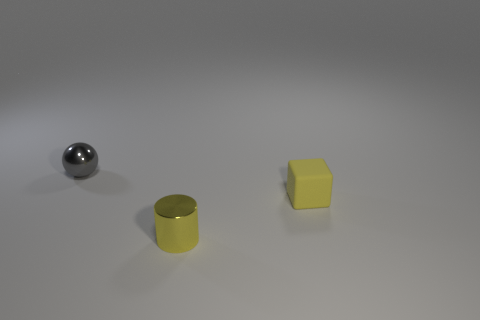In what kind of setting might you find these objects together? These objects could be found together in an educational setting, such as a classroom, where they might be used as teaching aids for lessons in geometry. Alternatively, they could be part of a collection of items for a still life drawing in an art class, allowing students to study shapes and reflections. 